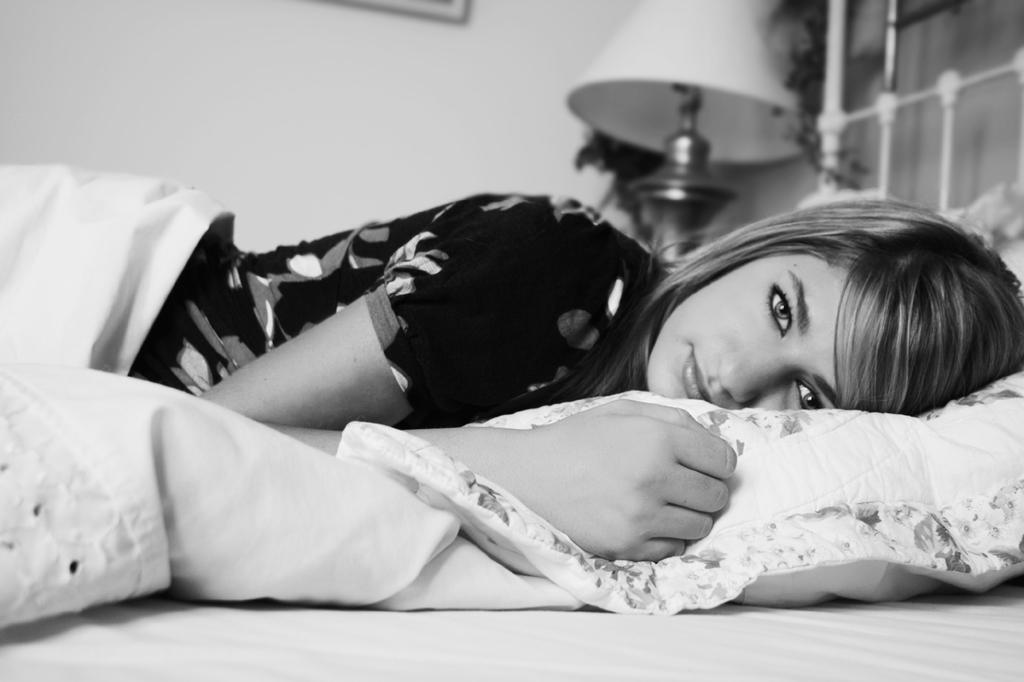Who is present in the image? There is a woman in the image. What is the woman doing in the image? The woman is lying on a bed. What is the woman wearing in the image? The woman is wearing a shirt with patterns. What is the color of the bed, bed sheet, and pillow in the image? The color of the bed, bed sheet, and pillow is white. How many oranges are on the woman's shirt in the image? There are no oranges present on the woman's shirt in the image. What type of jewel is the woman wearing in the image? The woman is not wearing any jewelry in the image. 